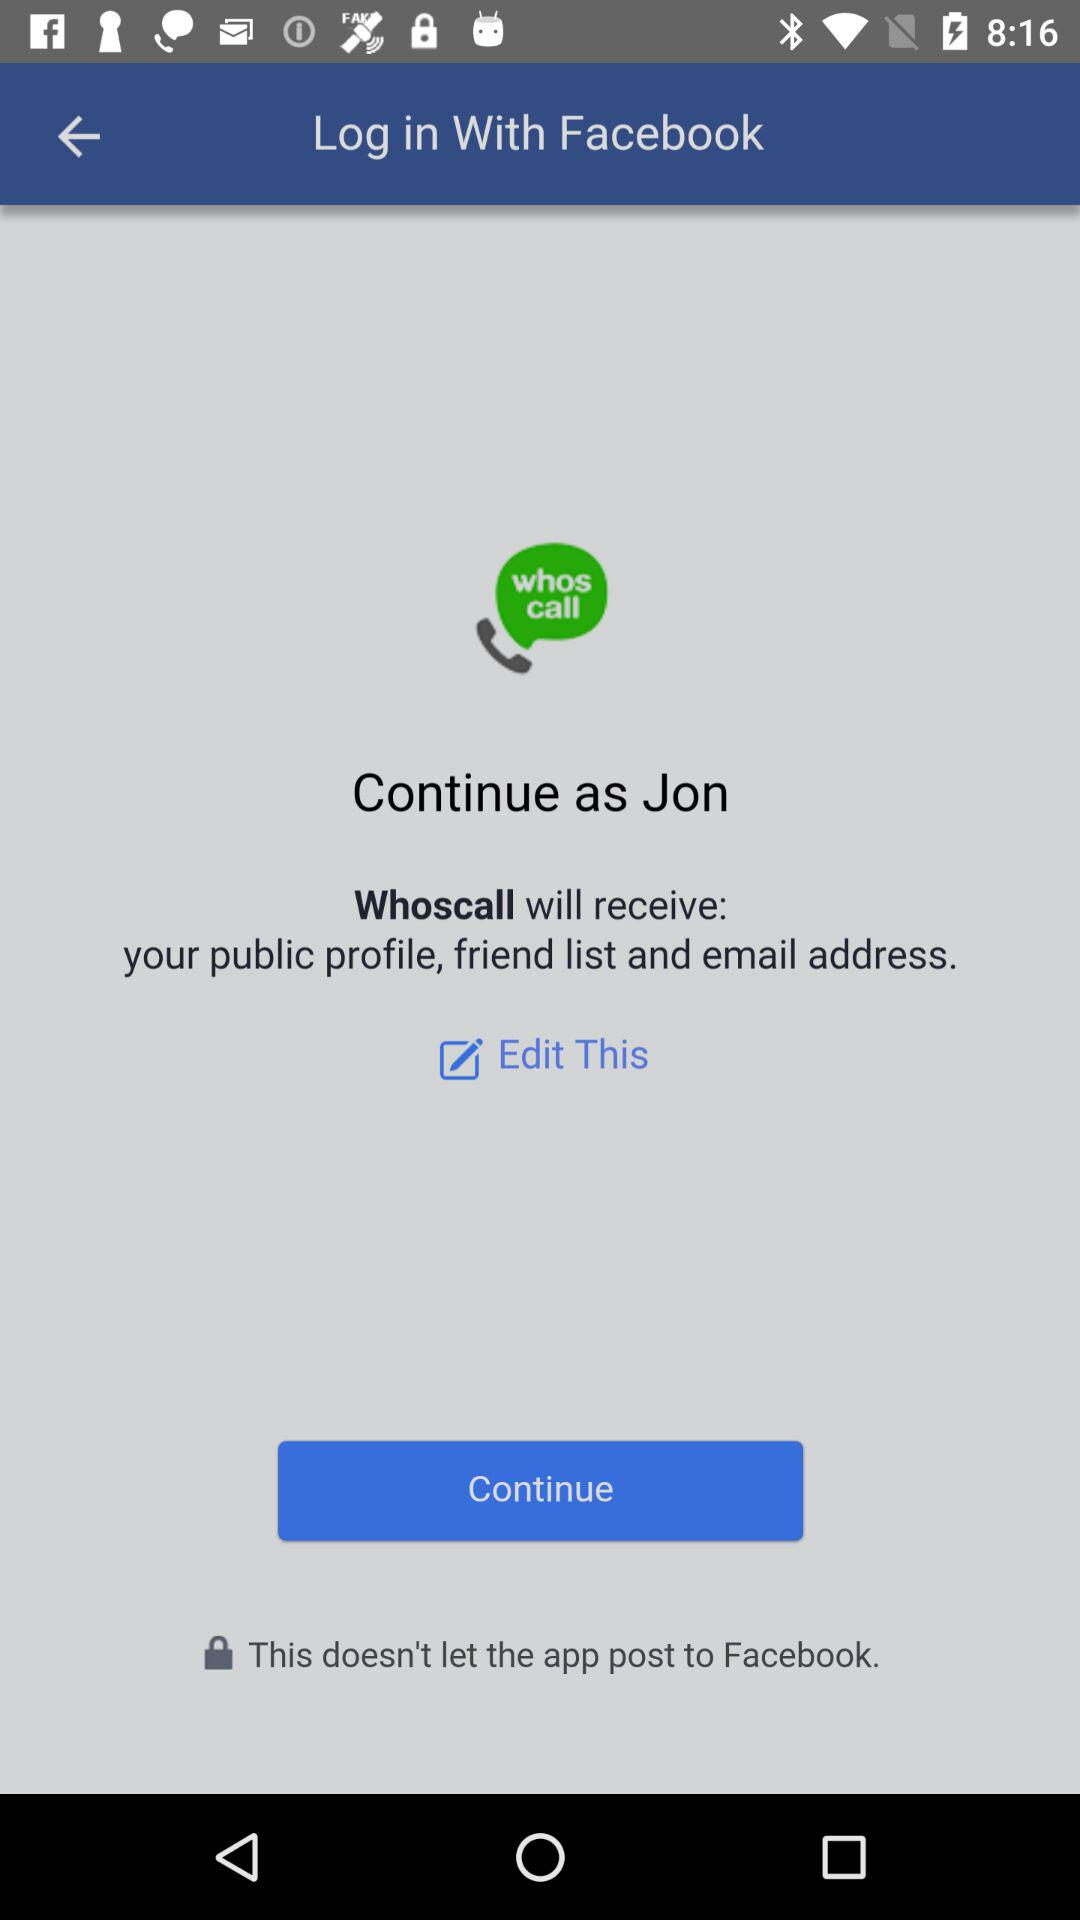What is the user name? The user name is Jon. 